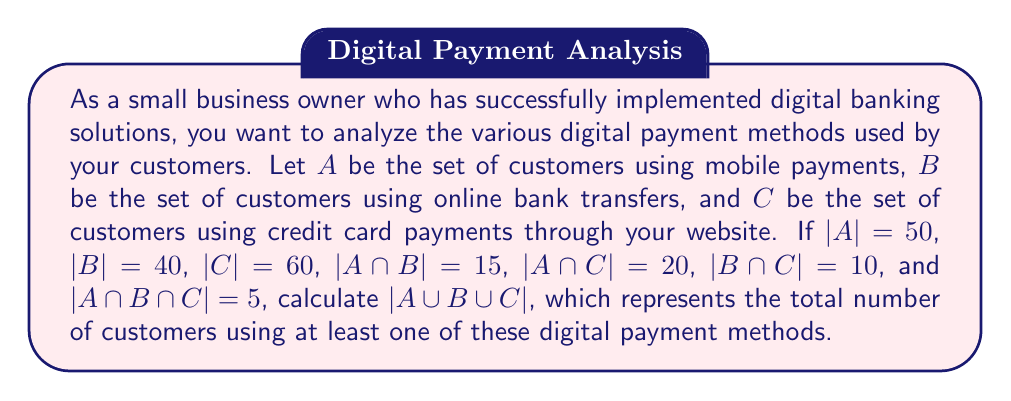What is the answer to this math problem? To solve this problem, we'll use the Inclusion-Exclusion Principle for three sets:

$$|A \cup B \cup C| = |A| + |B| + |C| - |A \cap B| - |A \cap C| - |B \cap C| + |A \cap B \cap C|$$

Let's substitute the given values:

1. $|A| = 50$
2. $|B| = 40$
3. $|C| = 60$
4. $|A \cap B| = 15$
5. $|A \cap C| = 20$
6. $|B \cap C| = 10$
7. $|A \cap B \cap C| = 5$

Now, let's calculate:

$$\begin{align*}
|A \cup B \cup C| &= |A| + |B| + |C| - |A \cap B| - |A \cap C| - |B \cap C| + |A \cap B \cap C| \\
&= 50 + 40 + 60 - 15 - 20 - 10 + 5 \\
&= 150 - 45 + 5 \\
&= 110
\end{align*}$$

Therefore, the total number of customers using at least one of these digital payment methods is 110.
Answer: $|A \cup B \cup C| = 110$ 